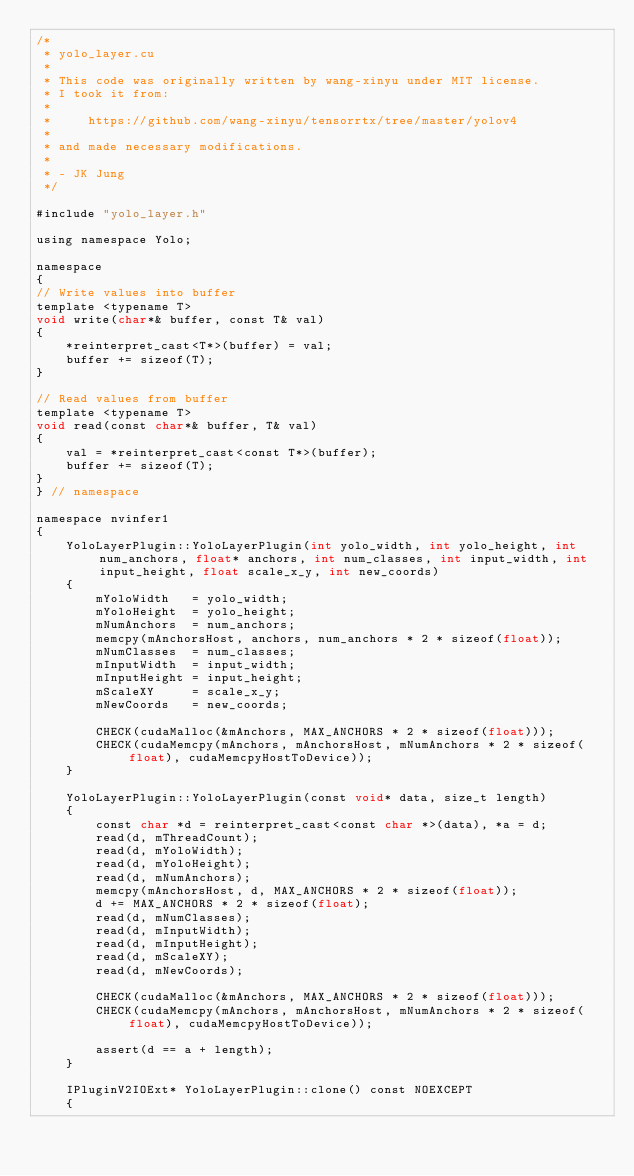<code> <loc_0><loc_0><loc_500><loc_500><_Cuda_>/*
 * yolo_layer.cu
 *
 * This code was originally written by wang-xinyu under MIT license.
 * I took it from:
 *
 *     https://github.com/wang-xinyu/tensorrtx/tree/master/yolov4
 *
 * and made necessary modifications.
 *
 * - JK Jung
 */

#include "yolo_layer.h"

using namespace Yolo;

namespace
{
// Write values into buffer
template <typename T>
void write(char*& buffer, const T& val)
{
    *reinterpret_cast<T*>(buffer) = val;
    buffer += sizeof(T);
}

// Read values from buffer
template <typename T>
void read(const char*& buffer, T& val)
{
    val = *reinterpret_cast<const T*>(buffer);
    buffer += sizeof(T);
}
} // namespace

namespace nvinfer1
{
    YoloLayerPlugin::YoloLayerPlugin(int yolo_width, int yolo_height, int num_anchors, float* anchors, int num_classes, int input_width, int input_height, float scale_x_y, int new_coords)
    {
        mYoloWidth   = yolo_width;
        mYoloHeight  = yolo_height;
        mNumAnchors  = num_anchors;
        memcpy(mAnchorsHost, anchors, num_anchors * 2 * sizeof(float));
        mNumClasses  = num_classes;
        mInputWidth  = input_width;
        mInputHeight = input_height;
        mScaleXY     = scale_x_y;
        mNewCoords   = new_coords;

        CHECK(cudaMalloc(&mAnchors, MAX_ANCHORS * 2 * sizeof(float)));
        CHECK(cudaMemcpy(mAnchors, mAnchorsHost, mNumAnchors * 2 * sizeof(float), cudaMemcpyHostToDevice));
    }

    YoloLayerPlugin::YoloLayerPlugin(const void* data, size_t length)
    {
        const char *d = reinterpret_cast<const char *>(data), *a = d;
        read(d, mThreadCount);
        read(d, mYoloWidth);
        read(d, mYoloHeight);
        read(d, mNumAnchors);
        memcpy(mAnchorsHost, d, MAX_ANCHORS * 2 * sizeof(float));
        d += MAX_ANCHORS * 2 * sizeof(float);
        read(d, mNumClasses);
        read(d, mInputWidth);
        read(d, mInputHeight);
        read(d, mScaleXY);
        read(d, mNewCoords);

        CHECK(cudaMalloc(&mAnchors, MAX_ANCHORS * 2 * sizeof(float)));
        CHECK(cudaMemcpy(mAnchors, mAnchorsHost, mNumAnchors * 2 * sizeof(float), cudaMemcpyHostToDevice));

        assert(d == a + length);
    }

    IPluginV2IOExt* YoloLayerPlugin::clone() const NOEXCEPT
    {</code> 